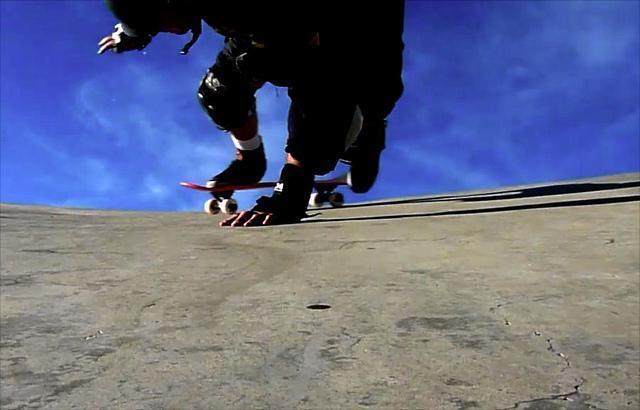How many zebras are facing left?
Give a very brief answer. 0. 